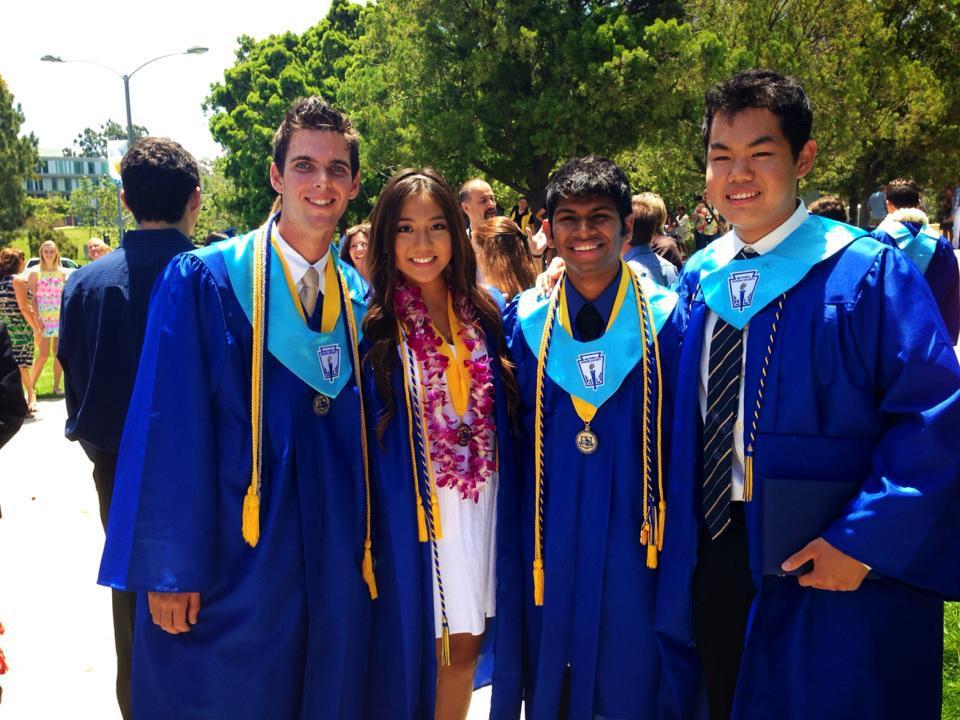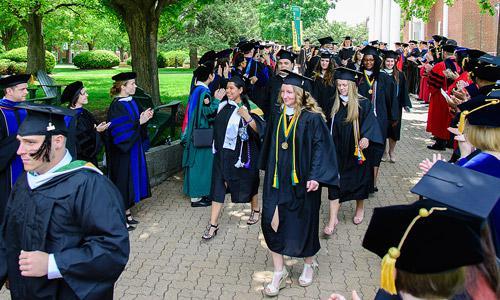The first image is the image on the left, the second image is the image on the right. For the images displayed, is the sentence "There is a single black male wearing a cap and gowns with a set of tassels hanging down around his neck." factually correct? Answer yes or no. No. The first image is the image on the left, the second image is the image on the right. Evaluate the accuracy of this statement regarding the images: "One image has exactly four people in the foreground.". Is it true? Answer yes or no. Yes. 